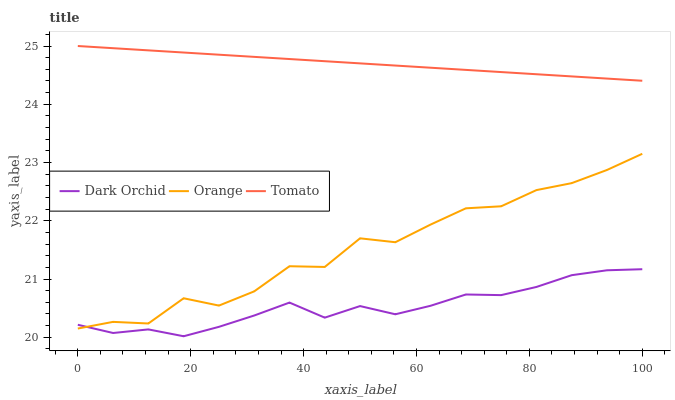Does Dark Orchid have the minimum area under the curve?
Answer yes or no. Yes. Does Tomato have the maximum area under the curve?
Answer yes or no. Yes. Does Tomato have the minimum area under the curve?
Answer yes or no. No. Does Dark Orchid have the maximum area under the curve?
Answer yes or no. No. Is Tomato the smoothest?
Answer yes or no. Yes. Is Orange the roughest?
Answer yes or no. Yes. Is Dark Orchid the smoothest?
Answer yes or no. No. Is Dark Orchid the roughest?
Answer yes or no. No. Does Dark Orchid have the lowest value?
Answer yes or no. Yes. Does Tomato have the lowest value?
Answer yes or no. No. Does Tomato have the highest value?
Answer yes or no. Yes. Does Dark Orchid have the highest value?
Answer yes or no. No. Is Dark Orchid less than Tomato?
Answer yes or no. Yes. Is Tomato greater than Dark Orchid?
Answer yes or no. Yes. Does Dark Orchid intersect Orange?
Answer yes or no. Yes. Is Dark Orchid less than Orange?
Answer yes or no. No. Is Dark Orchid greater than Orange?
Answer yes or no. No. Does Dark Orchid intersect Tomato?
Answer yes or no. No. 